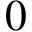<formula> <loc_0><loc_0><loc_500><loc_500>0</formula> 